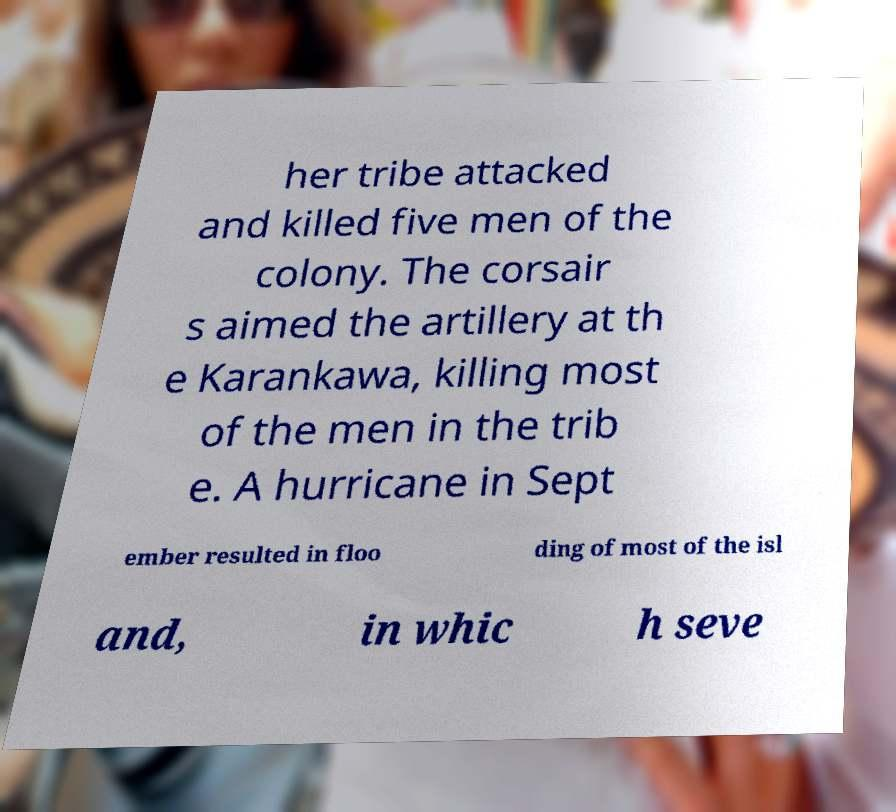Could you assist in decoding the text presented in this image and type it out clearly? her tribe attacked and killed five men of the colony. The corsair s aimed the artillery at th e Karankawa, killing most of the men in the trib e. A hurricane in Sept ember resulted in floo ding of most of the isl and, in whic h seve 